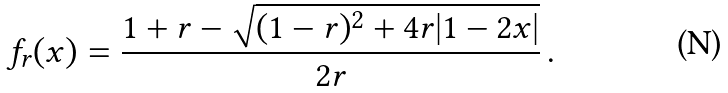<formula> <loc_0><loc_0><loc_500><loc_500>f _ { r } ( x ) = \frac { 1 + r - \sqrt { ( 1 - r ) ^ { 2 } + 4 r | 1 - 2 x | } } { 2 r } \, .</formula> 